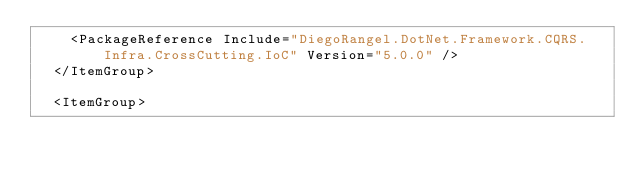Convert code to text. <code><loc_0><loc_0><loc_500><loc_500><_XML_>    <PackageReference Include="DiegoRangel.DotNet.Framework.CQRS.Infra.CrossCutting.IoC" Version="5.0.0" />
  </ItemGroup>

  <ItemGroup></code> 